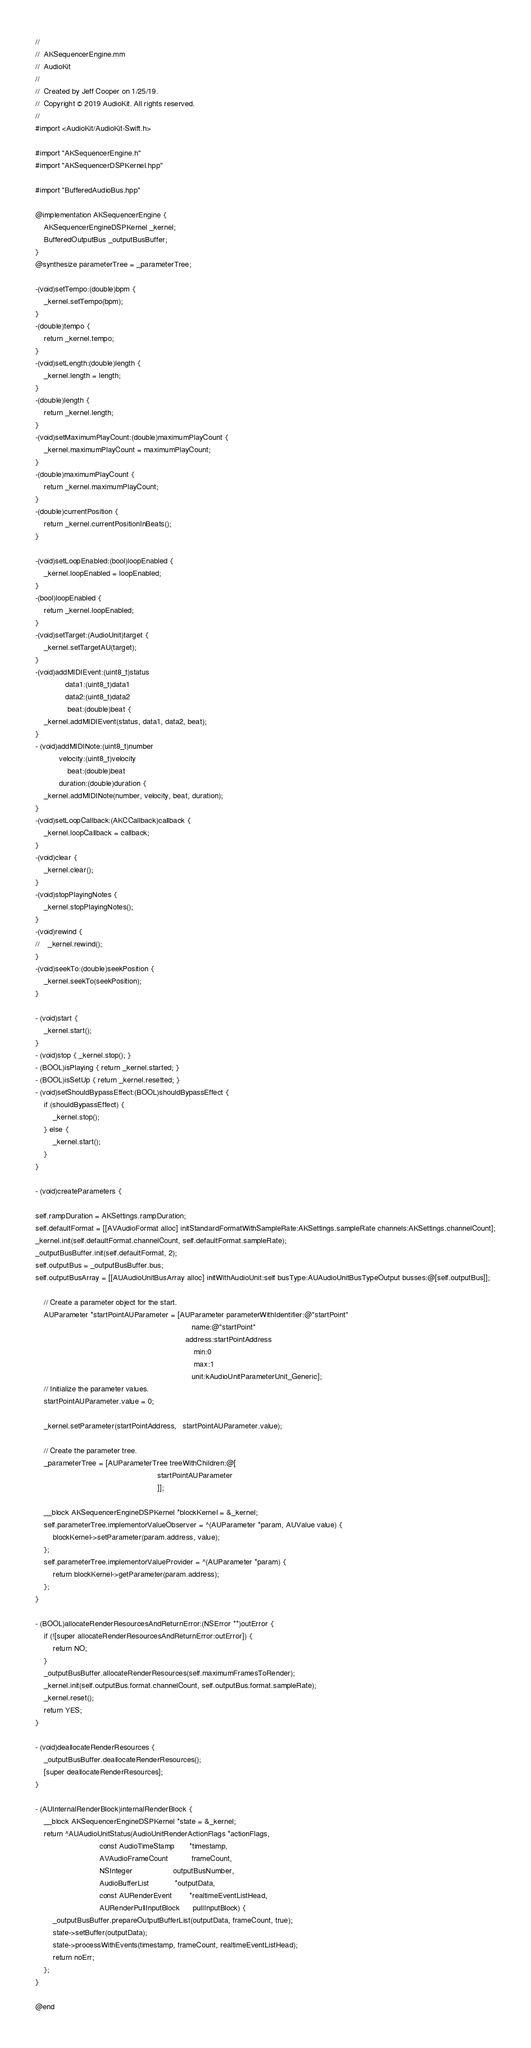Convert code to text. <code><loc_0><loc_0><loc_500><loc_500><_ObjectiveC_>//
//  AKSequencerEngine.mm
//  AudioKit
//
//  Created by Jeff Cooper on 1/25/19.
//  Copyright © 2019 AudioKit. All rights reserved.
//
#import <AudioKit/AudioKit-Swift.h>

#import "AKSequencerEngine.h"
#import "AKSequencerDSPKernel.hpp"

#import "BufferedAudioBus.hpp"

@implementation AKSequencerEngine {
    AKSequencerEngineDSPKernel _kernel;
    BufferedOutputBus _outputBusBuffer;
}
@synthesize parameterTree = _parameterTree;

-(void)setTempo:(double)bpm {
    _kernel.setTempo(bpm);
}
-(double)tempo {
    return _kernel.tempo;
}
-(void)setLength:(double)length {
    _kernel.length = length;
}
-(double)length {
    return _kernel.length;
}
-(void)setMaximumPlayCount:(double)maximumPlayCount {
    _kernel.maximumPlayCount = maximumPlayCount;
}
-(double)maximumPlayCount {
    return _kernel.maximumPlayCount;
}
-(double)currentPosition {
    return _kernel.currentPositionInBeats();
}

-(void)setLoopEnabled:(bool)loopEnabled {
    _kernel.loopEnabled = loopEnabled;
}
-(bool)loopEnabled {
    return _kernel.loopEnabled;
}
-(void)setTarget:(AudioUnit)target {
    _kernel.setTargetAU(target);
}
-(void)addMIDIEvent:(uint8_t)status
              data1:(uint8_t)data1
              data2:(uint8_t)data2
               beat:(double)beat {
    _kernel.addMIDIEvent(status, data1, data2, beat);
}
- (void)addMIDINote:(uint8_t)number
           velocity:(uint8_t)velocity
               beat:(double)beat
           duration:(double)duration {
    _kernel.addMIDINote(number, velocity, beat, duration);
}
-(void)setLoopCallback:(AKCCallback)callback {
    _kernel.loopCallback = callback;
}
-(void)clear {
    _kernel.clear();
}
-(void)stopPlayingNotes {
    _kernel.stopPlayingNotes();
}
-(void)rewind {
//    _kernel.rewind();
}
-(void)seekTo:(double)seekPosition {
    _kernel.seekTo(seekPosition);
}

- (void)start {
    _kernel.start();
}
- (void)stop { _kernel.stop(); }
- (BOOL)isPlaying { return _kernel.started; }
- (BOOL)isSetUp { return _kernel.resetted; }
- (void)setShouldBypassEffect:(BOOL)shouldBypassEffect {
    if (shouldBypassEffect) {
        _kernel.stop();
    } else {
        _kernel.start();
    }
}

- (void)createParameters {

self.rampDuration = AKSettings.rampDuration;
self.defaultFormat = [[AVAudioFormat alloc] initStandardFormatWithSampleRate:AKSettings.sampleRate channels:AKSettings.channelCount];
_kernel.init(self.defaultFormat.channelCount, self.defaultFormat.sampleRate);
_outputBusBuffer.init(self.defaultFormat, 2);
self.outputBus = _outputBusBuffer.bus;
self.outputBusArray = [[AUAudioUnitBusArray alloc] initWithAudioUnit:self busType:AUAudioUnitBusTypeOutput busses:@[self.outputBus]];

    // Create a parameter object for the start.
    AUParameter *startPointAUParameter = [AUParameter parameterWithIdentifier:@"startPoint"
                                                                         name:@"startPoint"
                                                                      address:startPointAddress
                                                                          min:0
                                                                          max:1
                                                                         unit:kAudioUnitParameterUnit_Generic];
    // Initialize the parameter values.
    startPointAUParameter.value = 0;

    _kernel.setParameter(startPointAddress,   startPointAUParameter.value);

    // Create the parameter tree.
    _parameterTree = [AUParameterTree treeWithChildren:@[
                                                         startPointAUParameter
                                                         ]];

    __block AKSequencerEngineDSPKernel *blockKernel = &_kernel;
    self.parameterTree.implementorValueObserver = ^(AUParameter *param, AUValue value) {
        blockKernel->setParameter(param.address, value);
    };
    self.parameterTree.implementorValueProvider = ^(AUParameter *param) {
        return blockKernel->getParameter(param.address);
    };
}

- (BOOL)allocateRenderResourcesAndReturnError:(NSError **)outError {
    if (![super allocateRenderResourcesAndReturnError:outError]) {
        return NO;
    }
    _outputBusBuffer.allocateRenderResources(self.maximumFramesToRender);
    _kernel.init(self.outputBus.format.channelCount, self.outputBus.format.sampleRate);
    _kernel.reset();
    return YES;
}

- (void)deallocateRenderResources {
    _outputBusBuffer.deallocateRenderResources();
    [super deallocateRenderResources];
}

- (AUInternalRenderBlock)internalRenderBlock {
    __block AKSequencerEngineDSPKernel *state = &_kernel;
    return ^AUAudioUnitStatus(AudioUnitRenderActionFlags *actionFlags,
                              const AudioTimeStamp       *timestamp,
                              AVAudioFrameCount           frameCount,
                              NSInteger                   outputBusNumber,
                              AudioBufferList            *outputData,
                              const AURenderEvent        *realtimeEventListHead,
                              AURenderPullInputBlock      pullInputBlock) {
        _outputBusBuffer.prepareOutputBufferList(outputData, frameCount, true);
        state->setBuffer(outputData);
        state->processWithEvents(timestamp, frameCount, realtimeEventListHead);
        return noErr;
    };
}

@end
</code> 